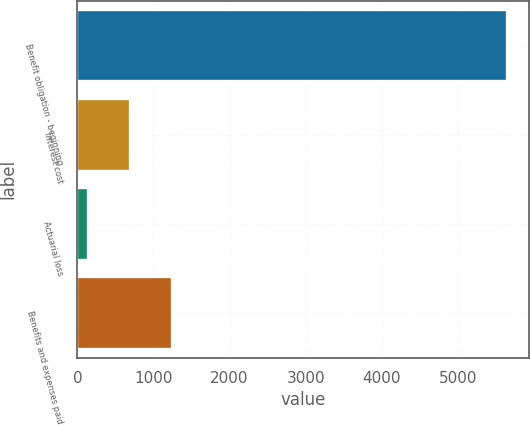Convert chart. <chart><loc_0><loc_0><loc_500><loc_500><bar_chart><fcel>Benefit obligation - beginning<fcel>Interest cost<fcel>Actuarial loss<fcel>Benefits and expenses paid<nl><fcel>5650<fcel>690.1<fcel>139<fcel>1241.2<nl></chart> 